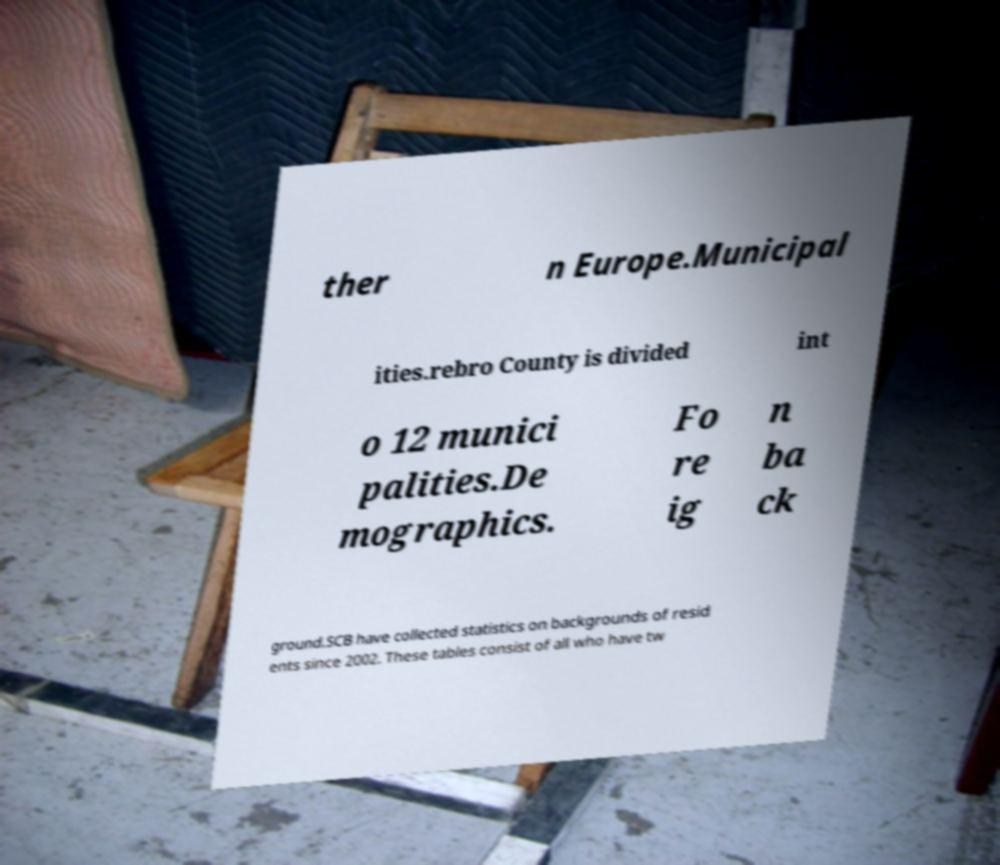Please identify and transcribe the text found in this image. ther n Europe.Municipal ities.rebro County is divided int o 12 munici palities.De mographics. Fo re ig n ba ck ground.SCB have collected statistics on backgrounds of resid ents since 2002. These tables consist of all who have tw 